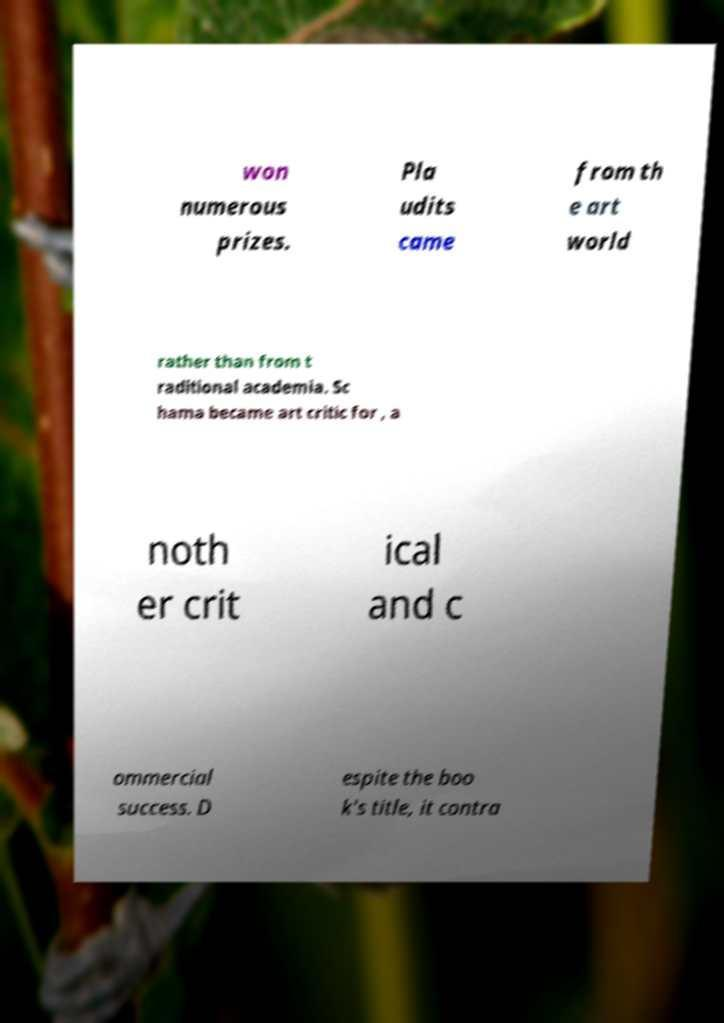Please read and relay the text visible in this image. What does it say? won numerous prizes. Pla udits came from th e art world rather than from t raditional academia. Sc hama became art critic for , a noth er crit ical and c ommercial success. D espite the boo k's title, it contra 